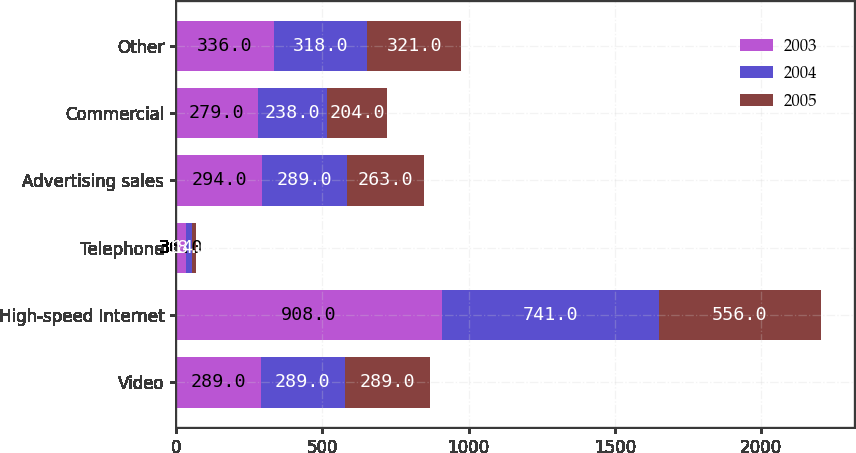<chart> <loc_0><loc_0><loc_500><loc_500><stacked_bar_chart><ecel><fcel>Video<fcel>High-speed Internet<fcel>Telephone<fcel>Advertising sales<fcel>Commercial<fcel>Other<nl><fcel>2003<fcel>289<fcel>908<fcel>36<fcel>294<fcel>279<fcel>336<nl><fcel>2004<fcel>289<fcel>741<fcel>18<fcel>289<fcel>238<fcel>318<nl><fcel>2005<fcel>289<fcel>556<fcel>14<fcel>263<fcel>204<fcel>321<nl></chart> 